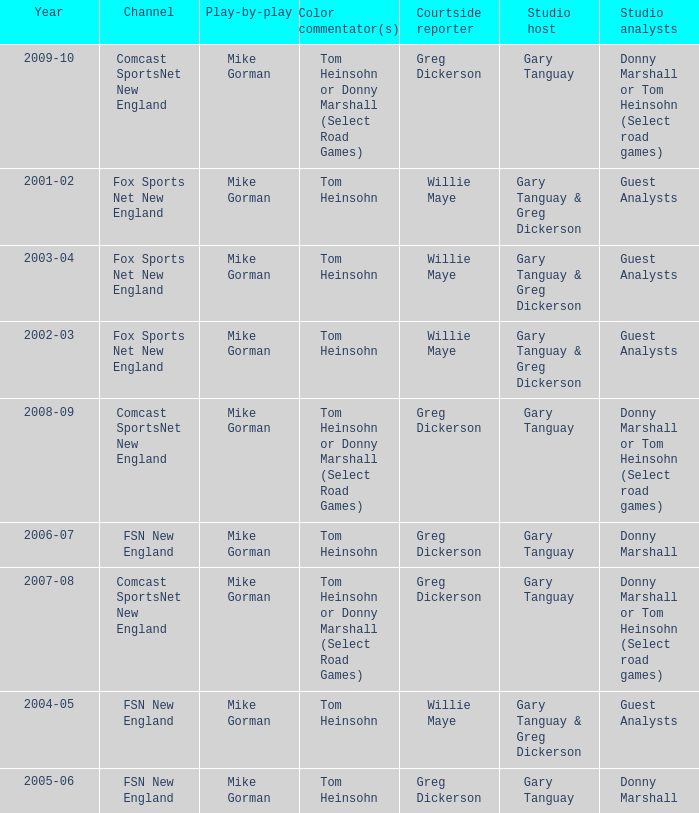Who is the courtside reporter for the year 2009-10? Greg Dickerson. 